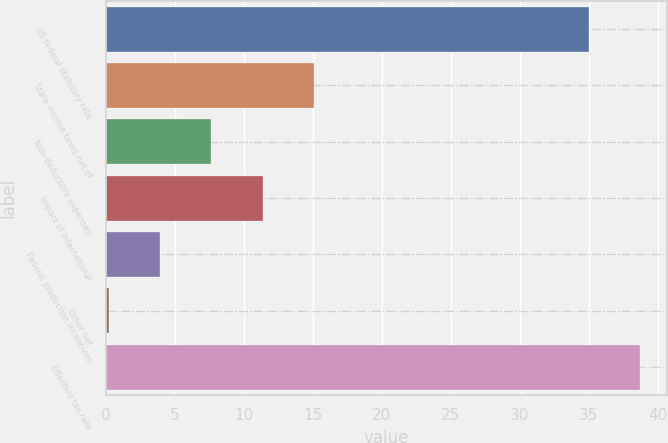Convert chart to OTSL. <chart><loc_0><loc_0><loc_500><loc_500><bar_chart><fcel>US federal statutory rate<fcel>State income taxes net of<fcel>Non-deductible expenses<fcel>Impact of international<fcel>Federal production incentives<fcel>Other net<fcel>Effective tax rate<nl><fcel>35<fcel>15.08<fcel>7.64<fcel>11.36<fcel>3.92<fcel>0.2<fcel>38.72<nl></chart> 